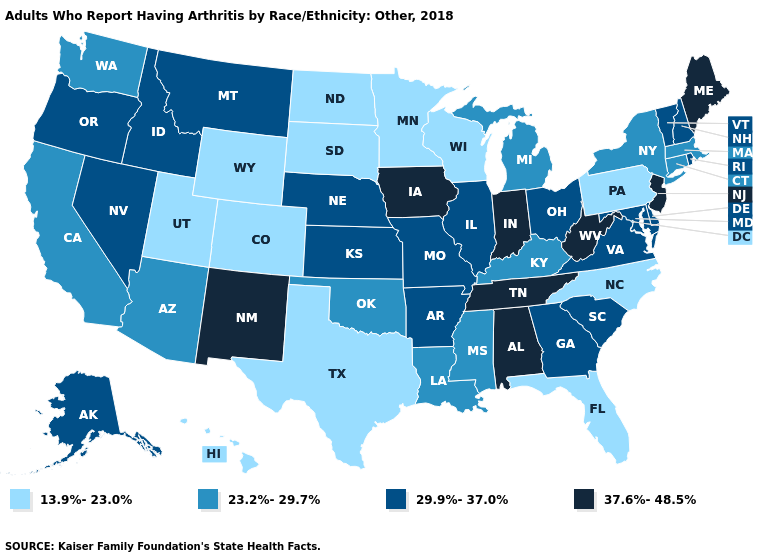Is the legend a continuous bar?
Write a very short answer. No. Which states have the lowest value in the USA?
Keep it brief. Colorado, Florida, Hawaii, Minnesota, North Carolina, North Dakota, Pennsylvania, South Dakota, Texas, Utah, Wisconsin, Wyoming. What is the value of Michigan?
Answer briefly. 23.2%-29.7%. Does the map have missing data?
Short answer required. No. What is the value of Iowa?
Be succinct. 37.6%-48.5%. Which states have the lowest value in the West?
Write a very short answer. Colorado, Hawaii, Utah, Wyoming. What is the value of Louisiana?
Short answer required. 23.2%-29.7%. How many symbols are there in the legend?
Write a very short answer. 4. What is the value of Ohio?
Answer briefly. 29.9%-37.0%. What is the value of Washington?
Quick response, please. 23.2%-29.7%. What is the value of New Jersey?
Write a very short answer. 37.6%-48.5%. What is the value of Wisconsin?
Answer briefly. 13.9%-23.0%. Name the states that have a value in the range 37.6%-48.5%?
Write a very short answer. Alabama, Indiana, Iowa, Maine, New Jersey, New Mexico, Tennessee, West Virginia. Name the states that have a value in the range 23.2%-29.7%?
Be succinct. Arizona, California, Connecticut, Kentucky, Louisiana, Massachusetts, Michigan, Mississippi, New York, Oklahoma, Washington. Does California have the same value as New Hampshire?
Answer briefly. No. 